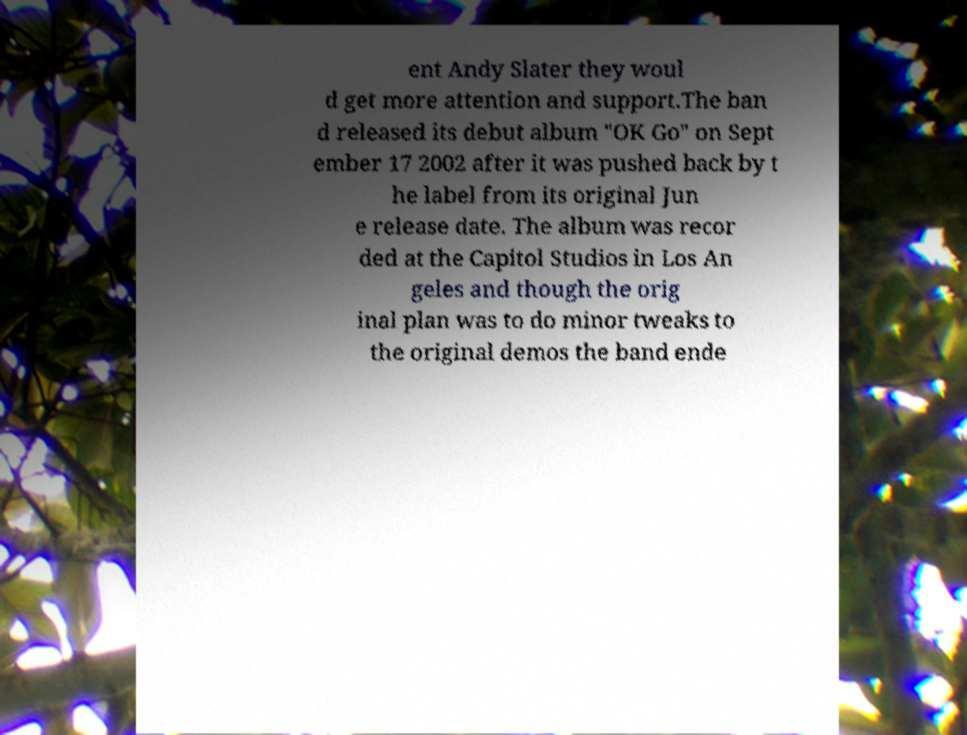I need the written content from this picture converted into text. Can you do that? ent Andy Slater they woul d get more attention and support.The ban d released its debut album "OK Go" on Sept ember 17 2002 after it was pushed back by t he label from its original Jun e release date. The album was recor ded at the Capitol Studios in Los An geles and though the orig inal plan was to do minor tweaks to the original demos the band ende 